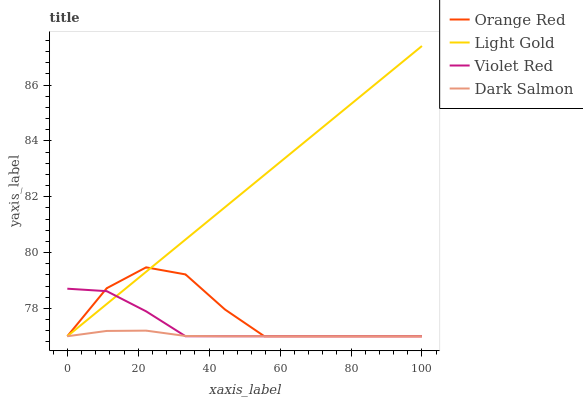Does Dark Salmon have the minimum area under the curve?
Answer yes or no. Yes. Does Light Gold have the maximum area under the curve?
Answer yes or no. Yes. Does Orange Red have the minimum area under the curve?
Answer yes or no. No. Does Orange Red have the maximum area under the curve?
Answer yes or no. No. Is Light Gold the smoothest?
Answer yes or no. Yes. Is Orange Red the roughest?
Answer yes or no. Yes. Is Orange Red the smoothest?
Answer yes or no. No. Is Light Gold the roughest?
Answer yes or no. No. Does Violet Red have the lowest value?
Answer yes or no. Yes. Does Light Gold have the highest value?
Answer yes or no. Yes. Does Orange Red have the highest value?
Answer yes or no. No. Does Light Gold intersect Orange Red?
Answer yes or no. Yes. Is Light Gold less than Orange Red?
Answer yes or no. No. Is Light Gold greater than Orange Red?
Answer yes or no. No. 